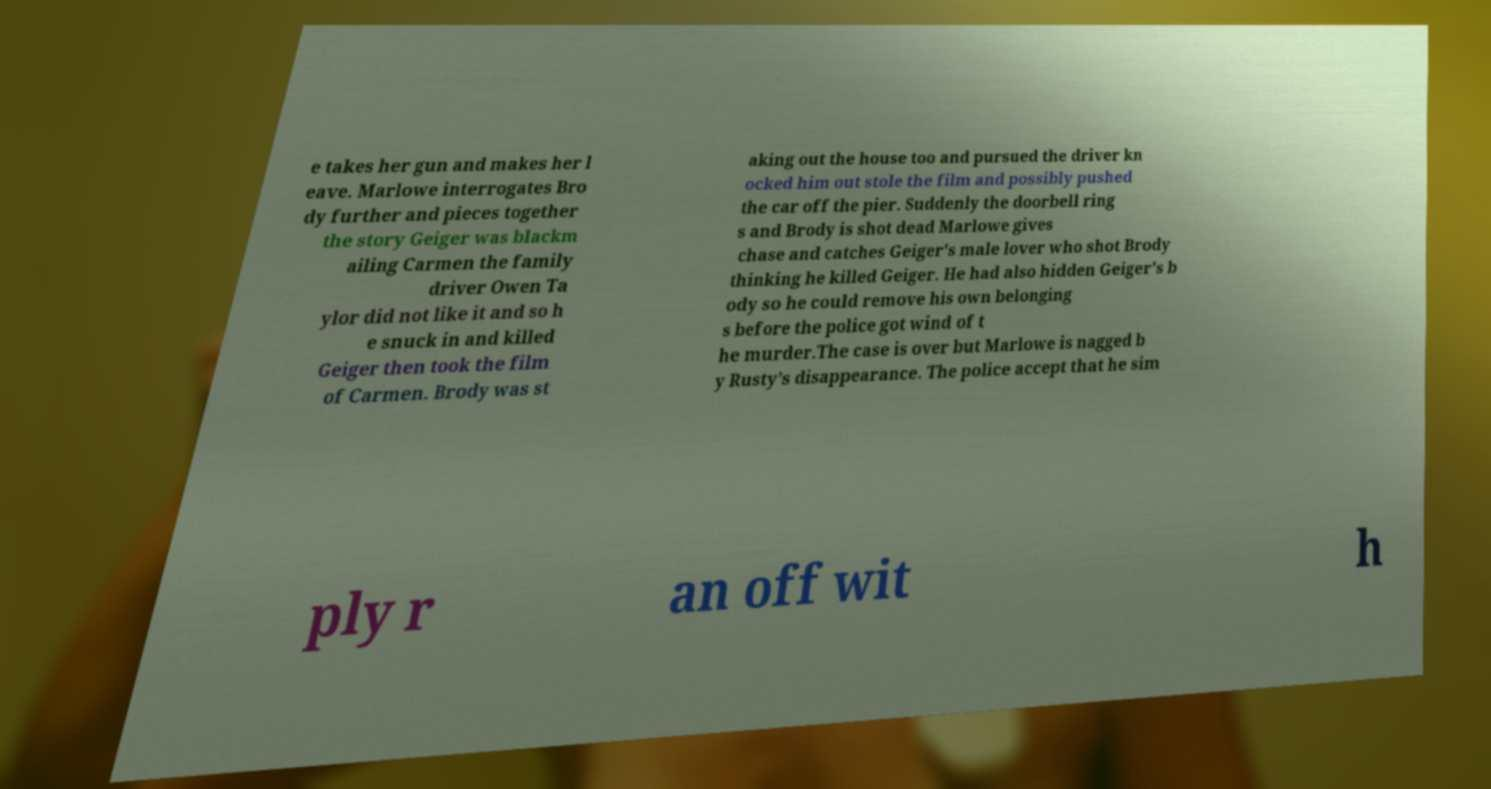Can you accurately transcribe the text from the provided image for me? e takes her gun and makes her l eave. Marlowe interrogates Bro dy further and pieces together the story Geiger was blackm ailing Carmen the family driver Owen Ta ylor did not like it and so h e snuck in and killed Geiger then took the film of Carmen. Brody was st aking out the house too and pursued the driver kn ocked him out stole the film and possibly pushed the car off the pier. Suddenly the doorbell ring s and Brody is shot dead Marlowe gives chase and catches Geiger's male lover who shot Brody thinking he killed Geiger. He had also hidden Geiger's b ody so he could remove his own belonging s before the police got wind of t he murder.The case is over but Marlowe is nagged b y Rusty’s disappearance. The police accept that he sim ply r an off wit h 